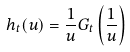Convert formula to latex. <formula><loc_0><loc_0><loc_500><loc_500>h _ { t } ( u ) = \frac { 1 } { u } G _ { t } \left ( \frac { 1 } { u } \right )</formula> 